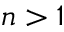Convert formula to latex. <formula><loc_0><loc_0><loc_500><loc_500>n > 1</formula> 